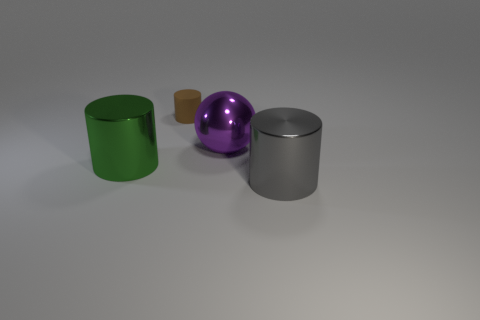Add 4 tiny yellow matte cylinders. How many objects exist? 8 Subtract all balls. How many objects are left? 3 Add 3 gray objects. How many gray objects are left? 4 Add 1 large purple spheres. How many large purple spheres exist? 2 Subtract 0 blue cylinders. How many objects are left? 4 Subtract all matte blocks. Subtract all purple things. How many objects are left? 3 